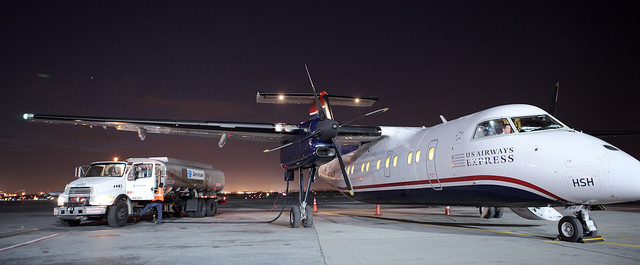Read and extract the text from this image. HSH EXPRESS US AIRWAYS 